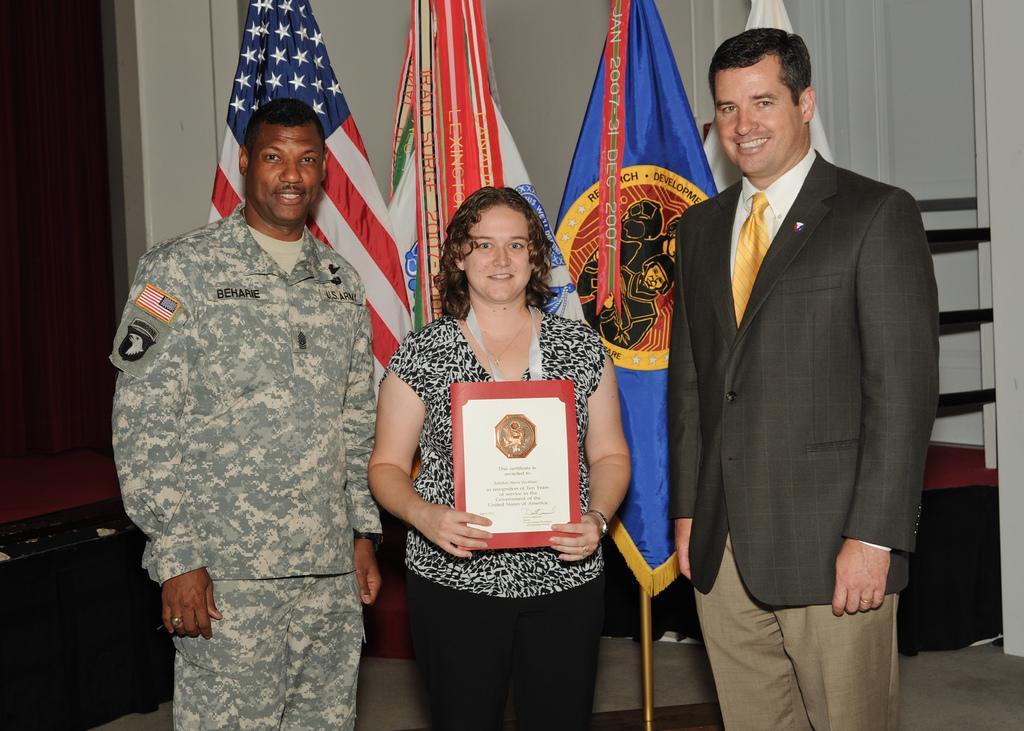In one or two sentences, can you explain what this image depicts? In the center of the image there is a woman holding a memorandum, beside the women there are two people standing, behind the woman there are flags, behind the flags there is a wall. 